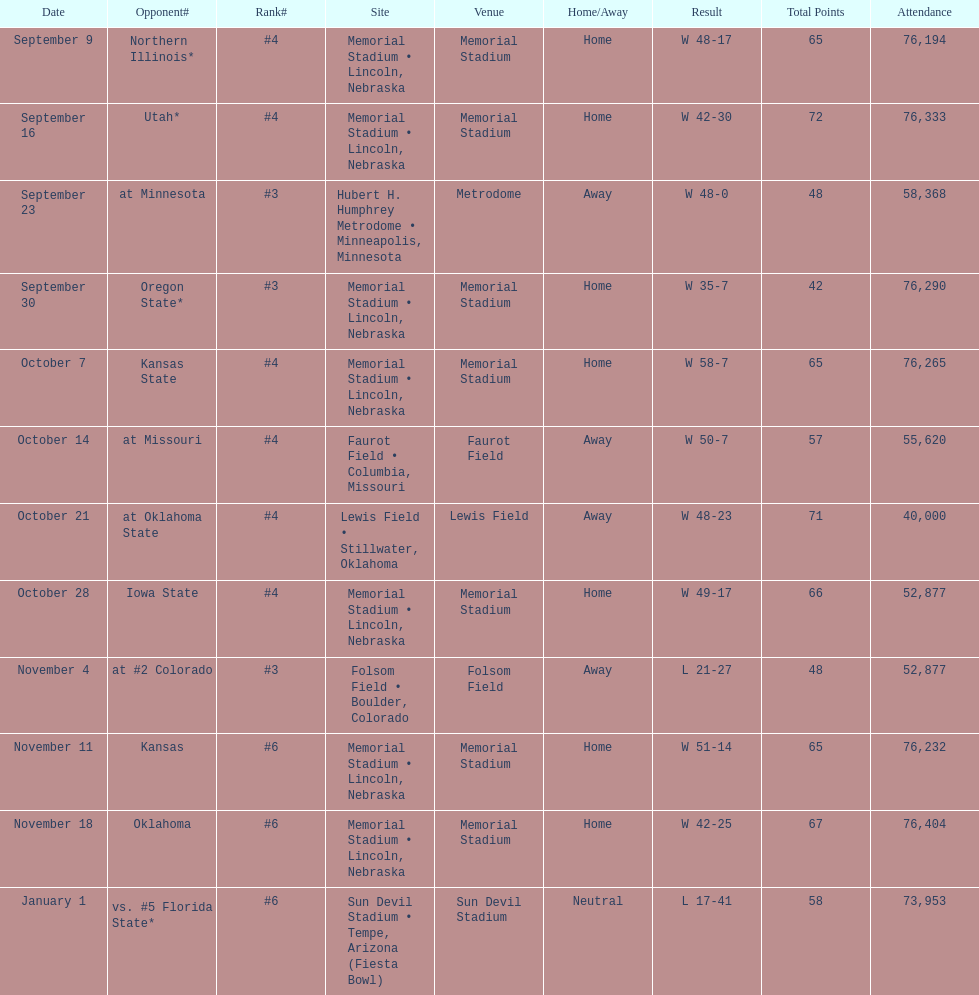What site at most is taken place? Memorial Stadium • Lincoln, Nebraska. Could you parse the entire table? {'header': ['Date', 'Opponent#', 'Rank#', 'Site', 'Venue', 'Home/Away', 'Result', 'Total Points', 'Attendance'], 'rows': [['September 9', 'Northern Illinois*', '#4', 'Memorial Stadium • Lincoln, Nebraska', 'Memorial Stadium', 'Home', 'W\xa048-17', '65', '76,194'], ['September 16', 'Utah*', '#4', 'Memorial Stadium • Lincoln, Nebraska', 'Memorial Stadium', 'Home', 'W\xa042-30', '72', '76,333'], ['September 23', 'at\xa0Minnesota', '#3', 'Hubert H. Humphrey Metrodome • Minneapolis, Minnesota', 'Metrodome', 'Away', 'W\xa048-0', '48', '58,368'], ['September 30', 'Oregon State*', '#3', 'Memorial Stadium • Lincoln, Nebraska', 'Memorial Stadium', 'Home', 'W\xa035-7', '42', '76,290'], ['October 7', 'Kansas State', '#4', 'Memorial Stadium • Lincoln, Nebraska', 'Memorial Stadium', 'Home', 'W\xa058-7', '65', '76,265'], ['October 14', 'at\xa0Missouri', '#4', 'Faurot Field • Columbia, Missouri', 'Faurot Field', 'Away', 'W\xa050-7', '57', '55,620'], ['October 21', 'at\xa0Oklahoma State', '#4', 'Lewis Field • Stillwater, Oklahoma', 'Lewis Field', 'Away', 'W\xa048-23', '71', '40,000'], ['October 28', 'Iowa State', '#4', 'Memorial Stadium • Lincoln, Nebraska', 'Memorial Stadium', 'Home', 'W\xa049-17', '66', '52,877'], ['November 4', 'at\xa0#2\xa0Colorado', '#3', 'Folsom Field • Boulder, Colorado', 'Folsom Field', 'Away', 'L\xa021-27', '48', '52,877'], ['November 11', 'Kansas', '#6', 'Memorial Stadium • Lincoln, Nebraska', 'Memorial Stadium', 'Home', 'W\xa051-14', '65', '76,232'], ['November 18', 'Oklahoma', '#6', 'Memorial Stadium • Lincoln, Nebraska', 'Memorial Stadium', 'Home', 'W\xa042-25', '67', '76,404'], ['January 1', 'vs.\xa0#5\xa0Florida State*', '#6', 'Sun Devil Stadium • Tempe, Arizona (Fiesta Bowl)', 'Sun Devil Stadium', 'Neutral', 'L\xa017-41', '58', '73,953']]} 